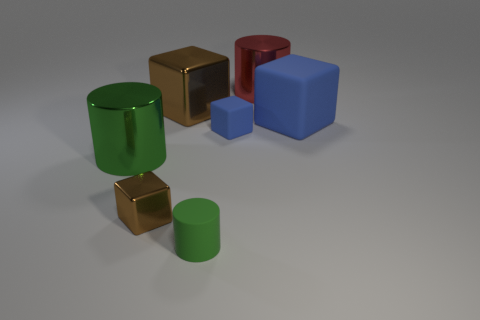Add 2 small green cylinders. How many objects exist? 9 Subtract all cylinders. How many objects are left? 4 Subtract 0 yellow blocks. How many objects are left? 7 Subtract all tiny red rubber cylinders. Subtract all tiny green objects. How many objects are left? 6 Add 5 brown metal cubes. How many brown metal cubes are left? 7 Add 2 red metallic cylinders. How many red metallic cylinders exist? 3 